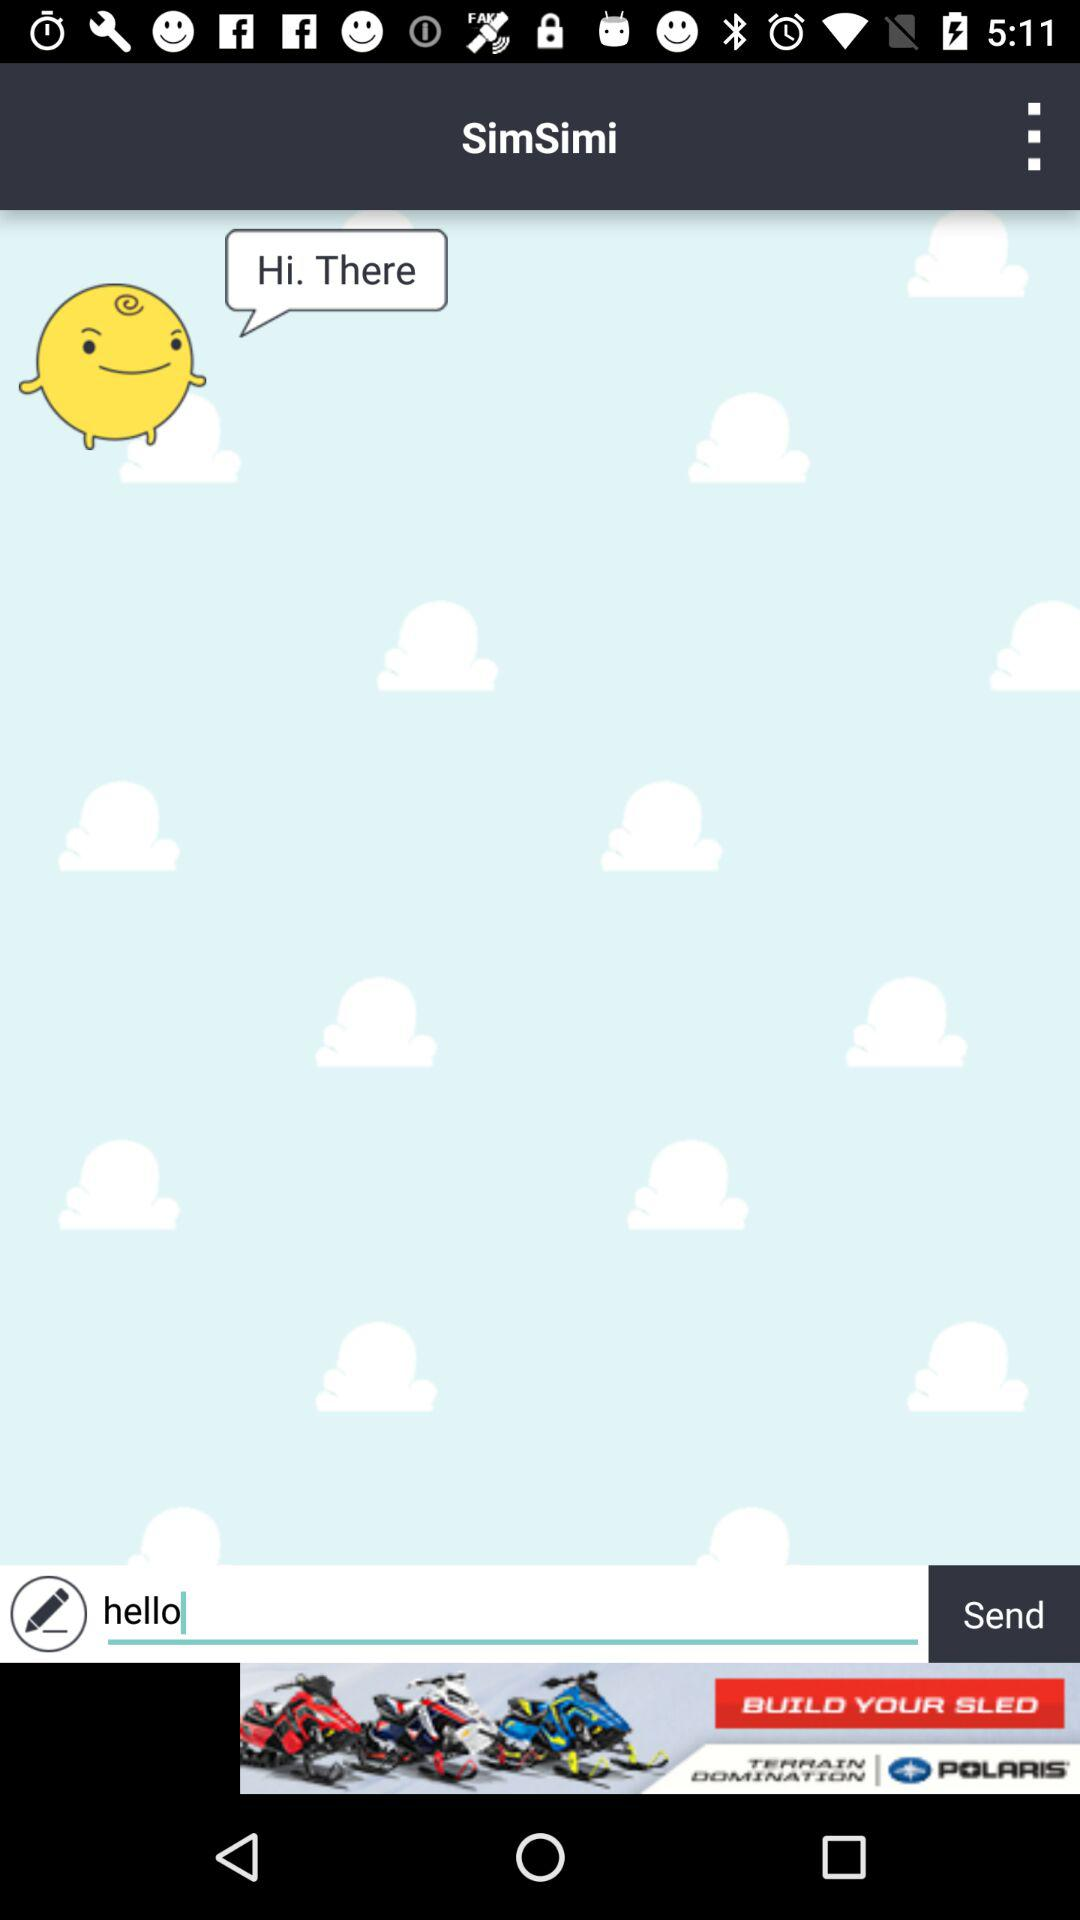How many text input elements are there?
Answer the question using a single word or phrase. 1 